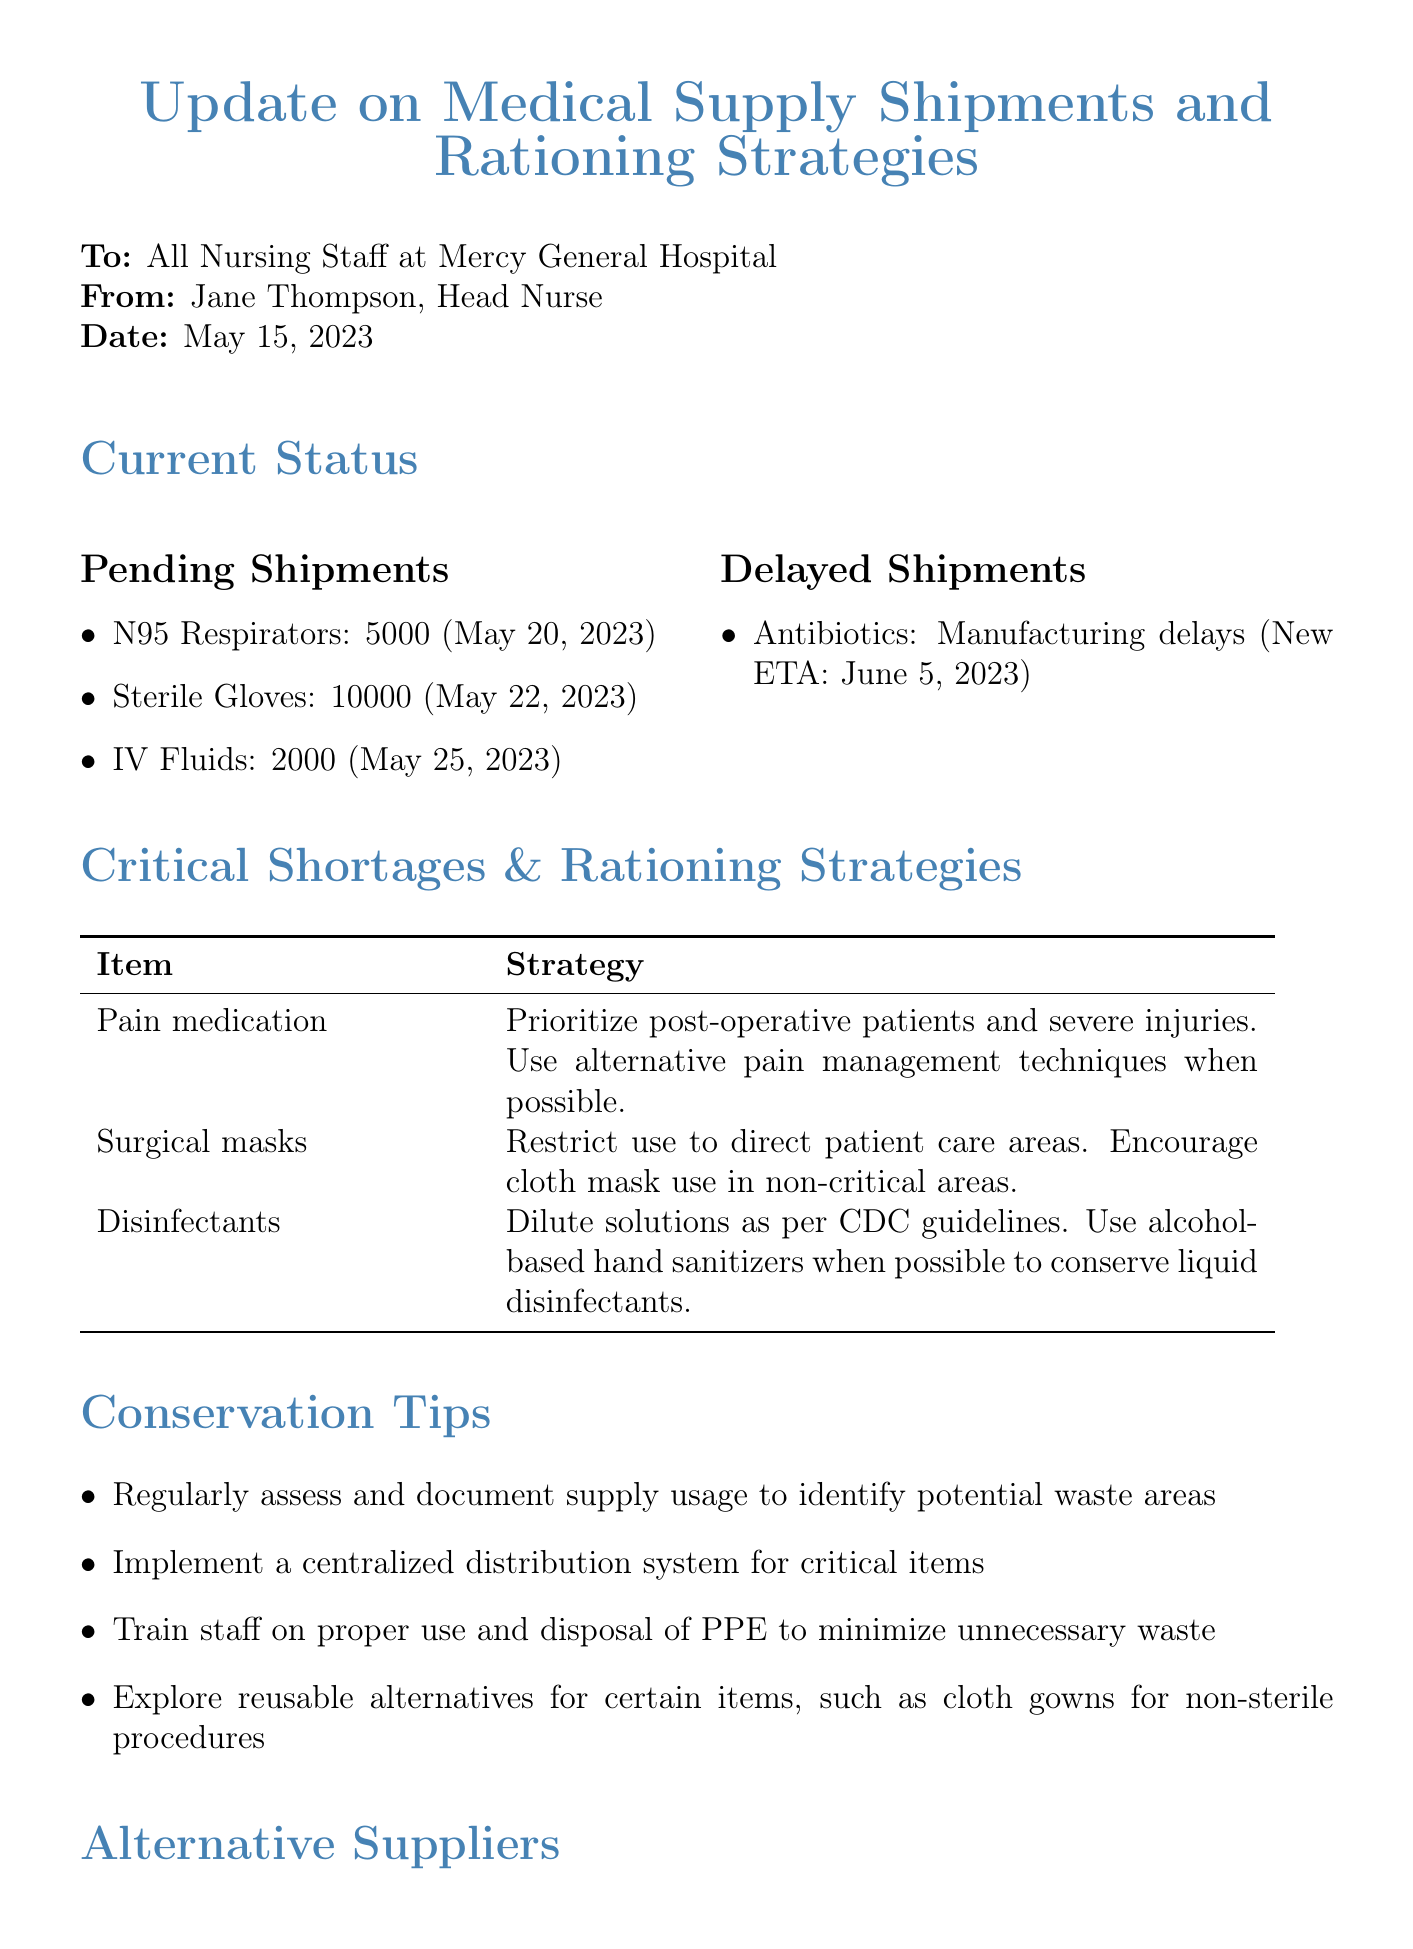What is the expected arrival date for N95 respirators? The memo specifies that N95 Respirators have an expected arrival date of May 20, 2023.
Answer: May 20, 2023 How many sterile gloves are pending shipment? The document states that there are 10,000 sterile gloves pending shipment.
Answer: 10000 What is the reason for the delay in antibiotics shipment? The memo mentions that antibiotics are delayed due to manufacturing delays.
Answer: Manufacturing delays Which item is prioritized for post-operative patients? The memo indicates that pain medication is prioritized for post-operative patients and those with severe injuries.
Answer: Pain medication Who is the presenter for the upcoming training session? The document lists Dr. Michael Chen as the presenter for the training session.
Answer: Dr. Michael Chen What are the two available items from MedLine Industries? The memo lists that MedLine Industries has surgical masks and disposable gowns available.
Answer: Surgical masks, Disposable gowns What strategy is suggested for disinfectants? The memo recommends diluting solutions as per CDC guidelines as a strategy for disinfectants.
Answer: Dilute solutions as per CDC guidelines When is the training on Advanced Resource Management scheduled? The document states that the training is scheduled for May 30, 2023.
Answer: May 30, 2023 How many IV fluids are expected to arrive? The memo indicates that 2,000 IV fluids are pending arrival.
Answer: 2000 